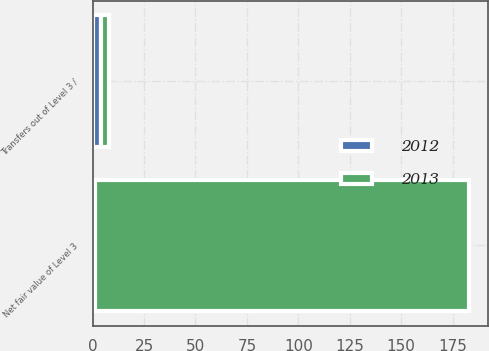Convert chart to OTSL. <chart><loc_0><loc_0><loc_500><loc_500><stacked_bar_chart><ecel><fcel>Transfers out of Level 3 /<fcel>Net fair value of Level 3<nl><fcel>2012<fcel>4<fcel>1<nl><fcel>2013<fcel>4<fcel>182<nl></chart> 